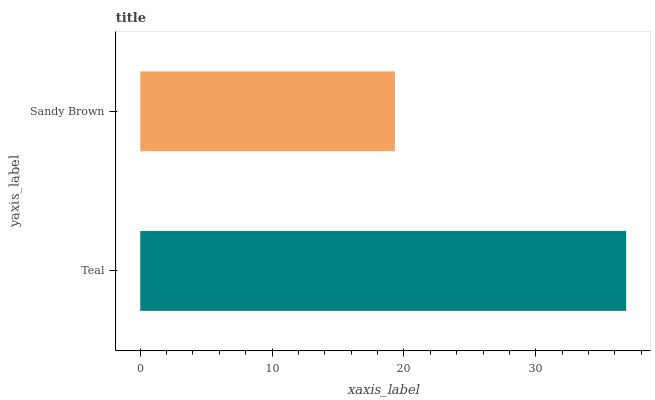Is Sandy Brown the minimum?
Answer yes or no. Yes. Is Teal the maximum?
Answer yes or no. Yes. Is Sandy Brown the maximum?
Answer yes or no. No. Is Teal greater than Sandy Brown?
Answer yes or no. Yes. Is Sandy Brown less than Teal?
Answer yes or no. Yes. Is Sandy Brown greater than Teal?
Answer yes or no. No. Is Teal less than Sandy Brown?
Answer yes or no. No. Is Teal the high median?
Answer yes or no. Yes. Is Sandy Brown the low median?
Answer yes or no. Yes. Is Sandy Brown the high median?
Answer yes or no. No. Is Teal the low median?
Answer yes or no. No. 